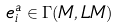Convert formula to latex. <formula><loc_0><loc_0><loc_500><loc_500>e ^ { a } _ { i } \in \Gamma ( M , L M )</formula> 